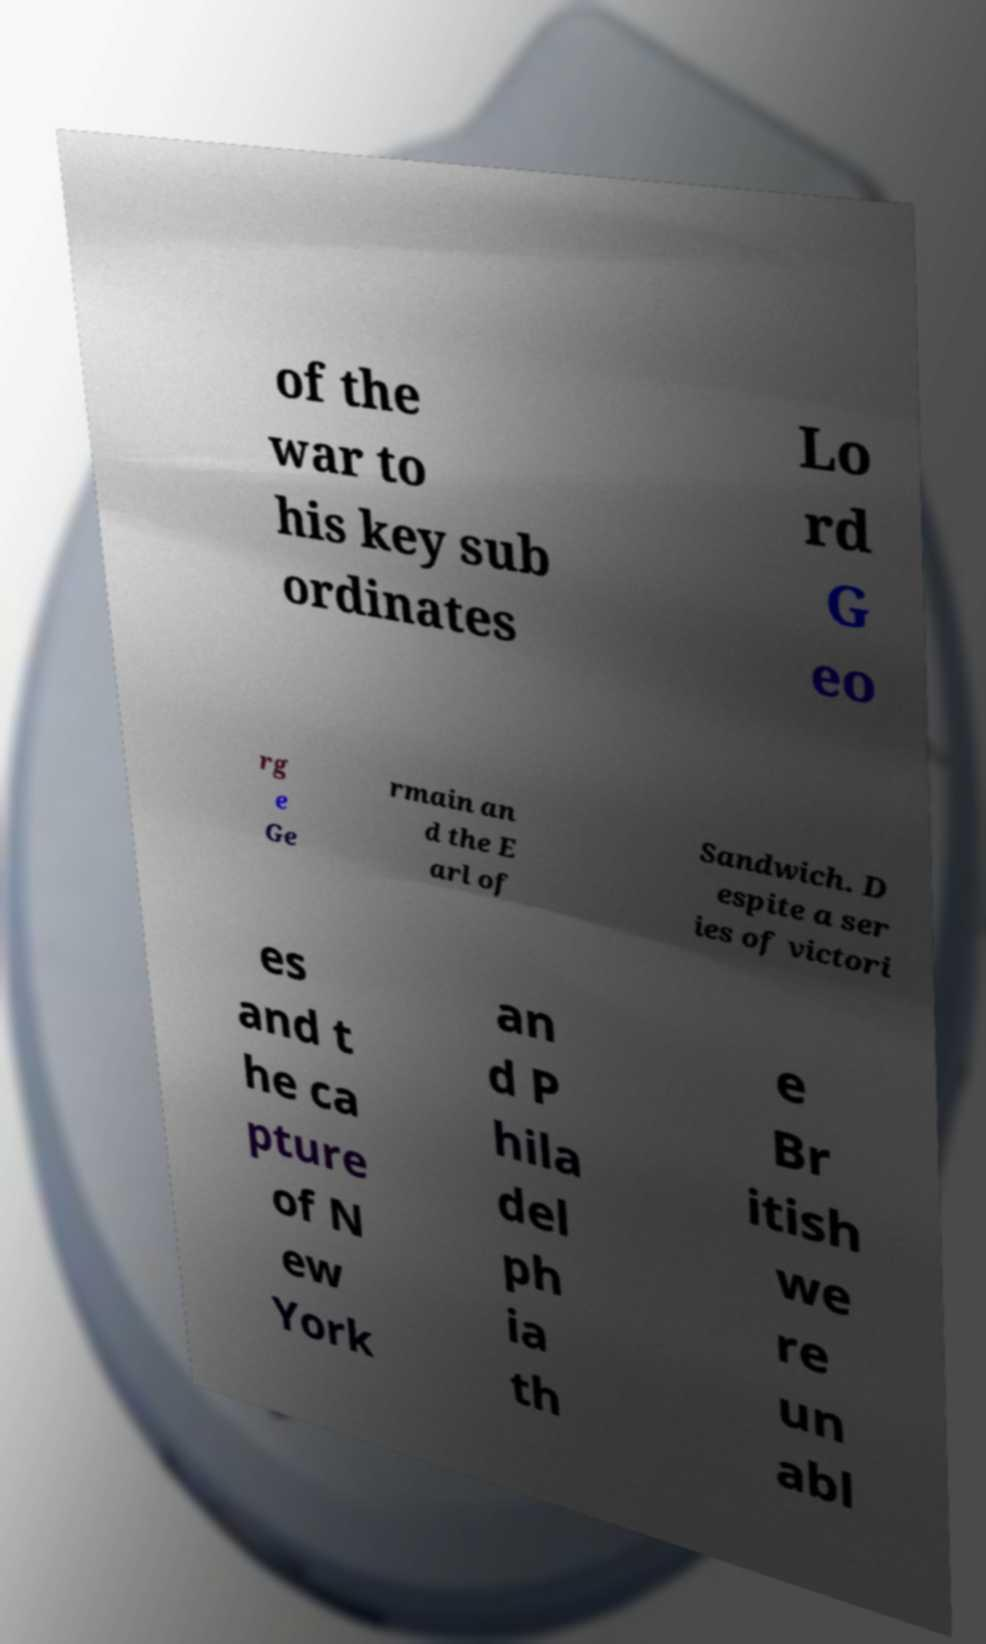I need the written content from this picture converted into text. Can you do that? of the war to his key sub ordinates Lo rd G eo rg e Ge rmain an d the E arl of Sandwich. D espite a ser ies of victori es and t he ca pture of N ew York an d P hila del ph ia th e Br itish we re un abl 